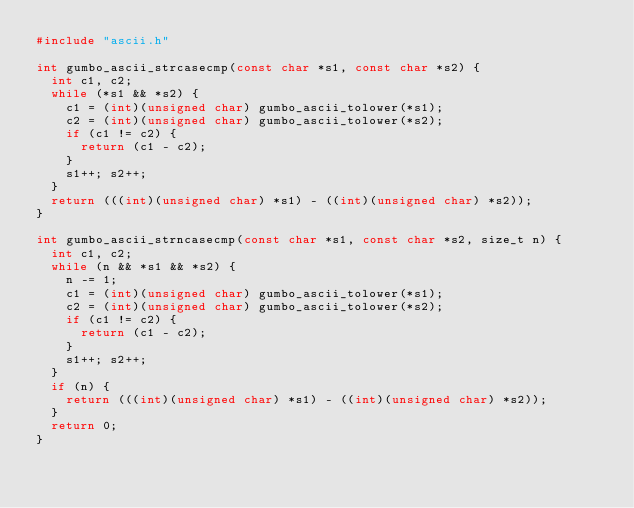Convert code to text. <code><loc_0><loc_0><loc_500><loc_500><_C_>#include "ascii.h"

int gumbo_ascii_strcasecmp(const char *s1, const char *s2) {
  int c1, c2;
  while (*s1 && *s2) {
    c1 = (int)(unsigned char) gumbo_ascii_tolower(*s1);
    c2 = (int)(unsigned char) gumbo_ascii_tolower(*s2);
    if (c1 != c2) {
      return (c1 - c2);
    }
    s1++; s2++;
  }
  return (((int)(unsigned char) *s1) - ((int)(unsigned char) *s2));
}

int gumbo_ascii_strncasecmp(const char *s1, const char *s2, size_t n) {
  int c1, c2;
  while (n && *s1 && *s2) {
    n -= 1;
    c1 = (int)(unsigned char) gumbo_ascii_tolower(*s1);
    c2 = (int)(unsigned char) gumbo_ascii_tolower(*s2);
    if (c1 != c2) {
      return (c1 - c2);
    }
    s1++; s2++;
  }
  if (n) {
    return (((int)(unsigned char) *s1) - ((int)(unsigned char) *s2));
  }
  return 0;
}
</code> 